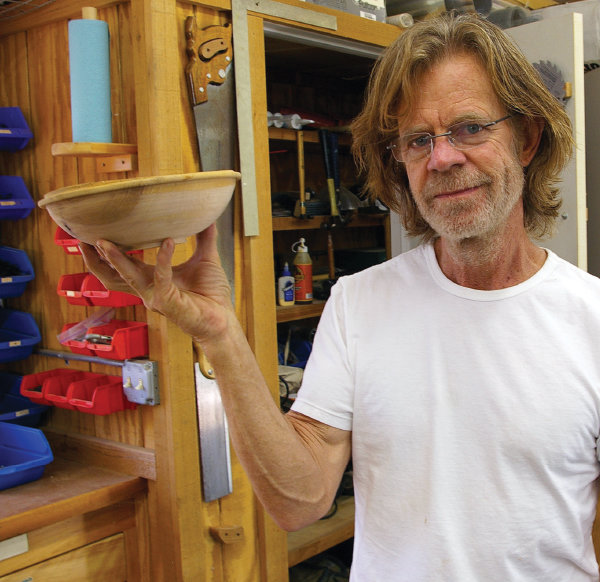Explain the visual content of the image in great detail. In this image, the renowned actor William H. Macy is captured in a moment of tranquility in his woodshop. He stands in the center of the frame, holding a wooden bowl in his right hand. His attire is simple and casual, consisting of a white t-shirt and a pair of glasses resting on his nose. A slight smile graces his face as he looks directly into the camera, giving us a glimpse into his world away from the big screen.

The woodshop behind him is filled with various tools and supplies neatly arranged on shelves, indicating his passion for woodworking. The colors in the image are warm and inviting, reflecting the natural tones of the wood around him. This image beautifully encapsulates William H. Macy's off-screen persona and his love for craftsmanship. 